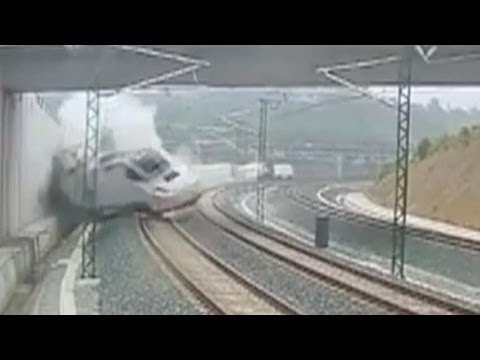Describe the objects in this image and their specific colors. I can see a train in black, darkgray, gray, and lightgray tones in this image. 